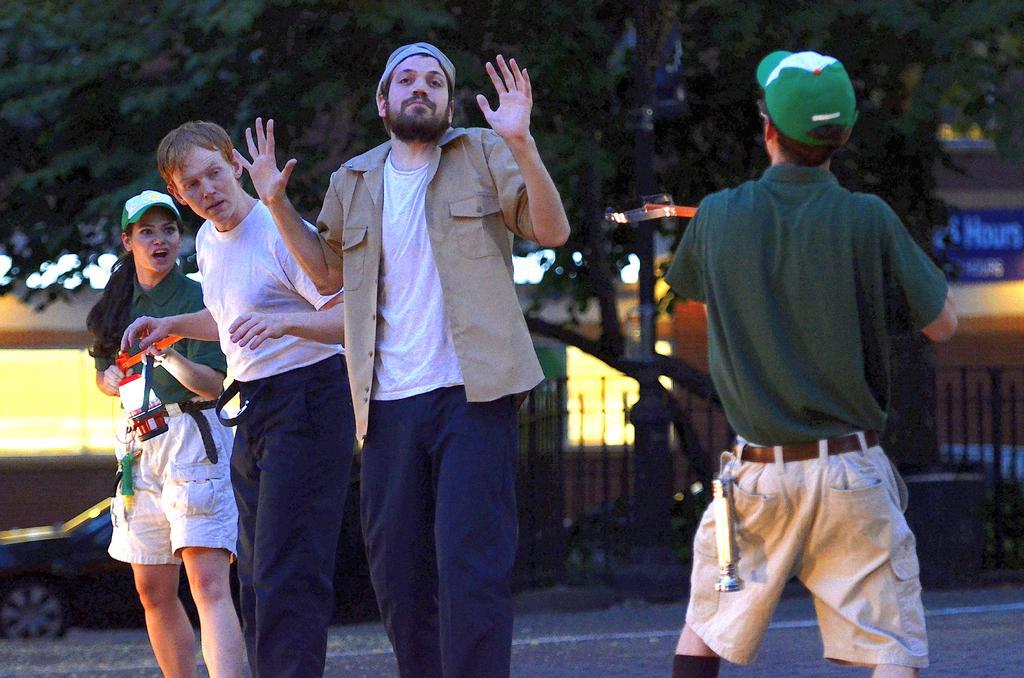Describe this image in one or two sentences. In this image there are group of persons standing in the center. In the background there are trees, there is a fence and there is a board with some text written on it. On the left side there is a woman standing wearing a green colour t-shirt and green colour hat is holding a red colour object in her hand. 